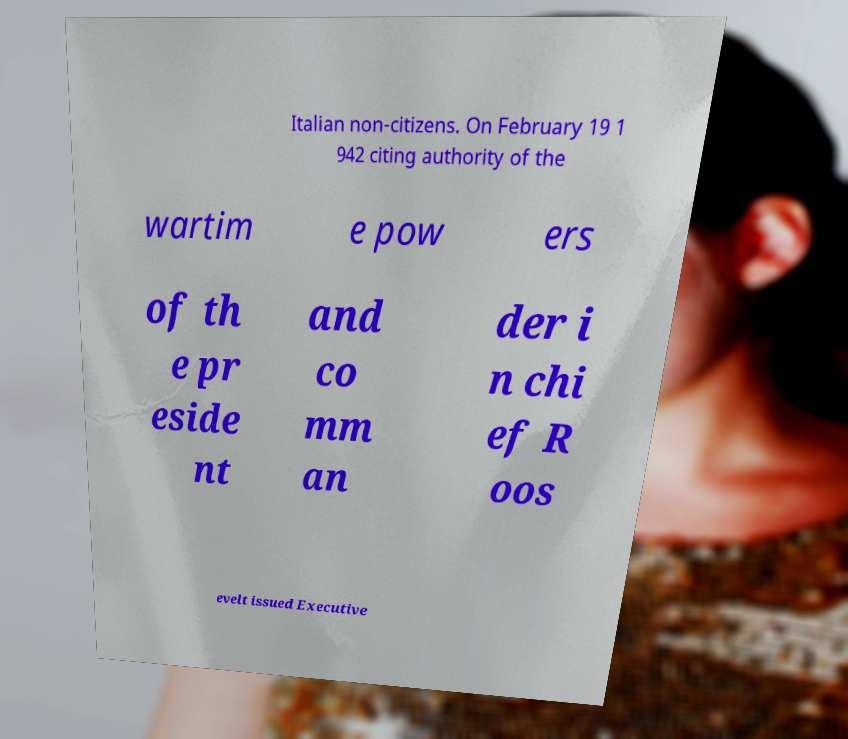Please identify and transcribe the text found in this image. Italian non-citizens. On February 19 1 942 citing authority of the wartim e pow ers of th e pr eside nt and co mm an der i n chi ef R oos evelt issued Executive 